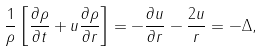<formula> <loc_0><loc_0><loc_500><loc_500>\frac { 1 } { \rho } \left [ { \frac { \partial \rho } { \partial t } + u \frac { \partial \rho } { \partial r } } \right ] = - \frac { \partial u } { \partial r } - \frac { 2 u } { r } = - \Delta ,</formula> 